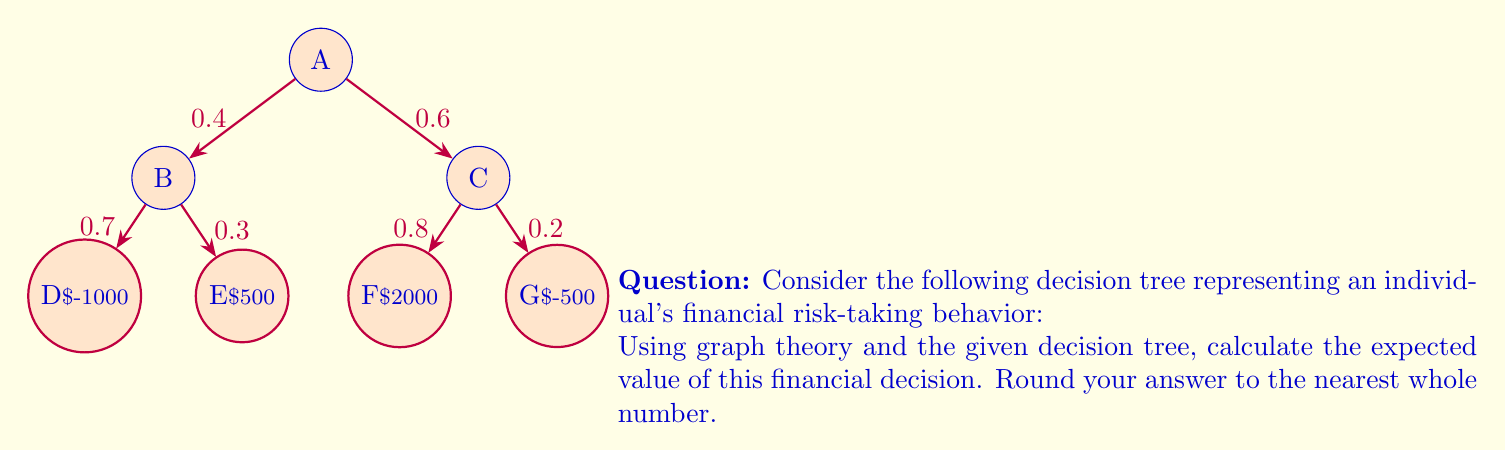What is the answer to this math problem? To solve this problem, we'll use the concept of expected value in decision trees:

1) First, we need to calculate the expected value of each decision branch:

   For branch B:
   $E(B) = 0.7 \times (-1000) + 0.3 \times 500 = -700 + 150 = -550$

   For branch C:
   $E(C) = 0.8 \times 2000 + 0.2 \times (-500) = 1600 - 100 = 1500$

2) Now, we can calculate the expected value of the entire decision:

   $E(A) = 0.4 \times E(B) + 0.6 \times E(C)$
   
   $E(A) = 0.4 \times (-550) + 0.6 \times 1500$
   
   $E(A) = -220 + 900 = 680$

3) Rounding to the nearest whole number:

   $E(A) \approx 680$

Therefore, the expected value of this financial decision is $680.
Answer: $680 